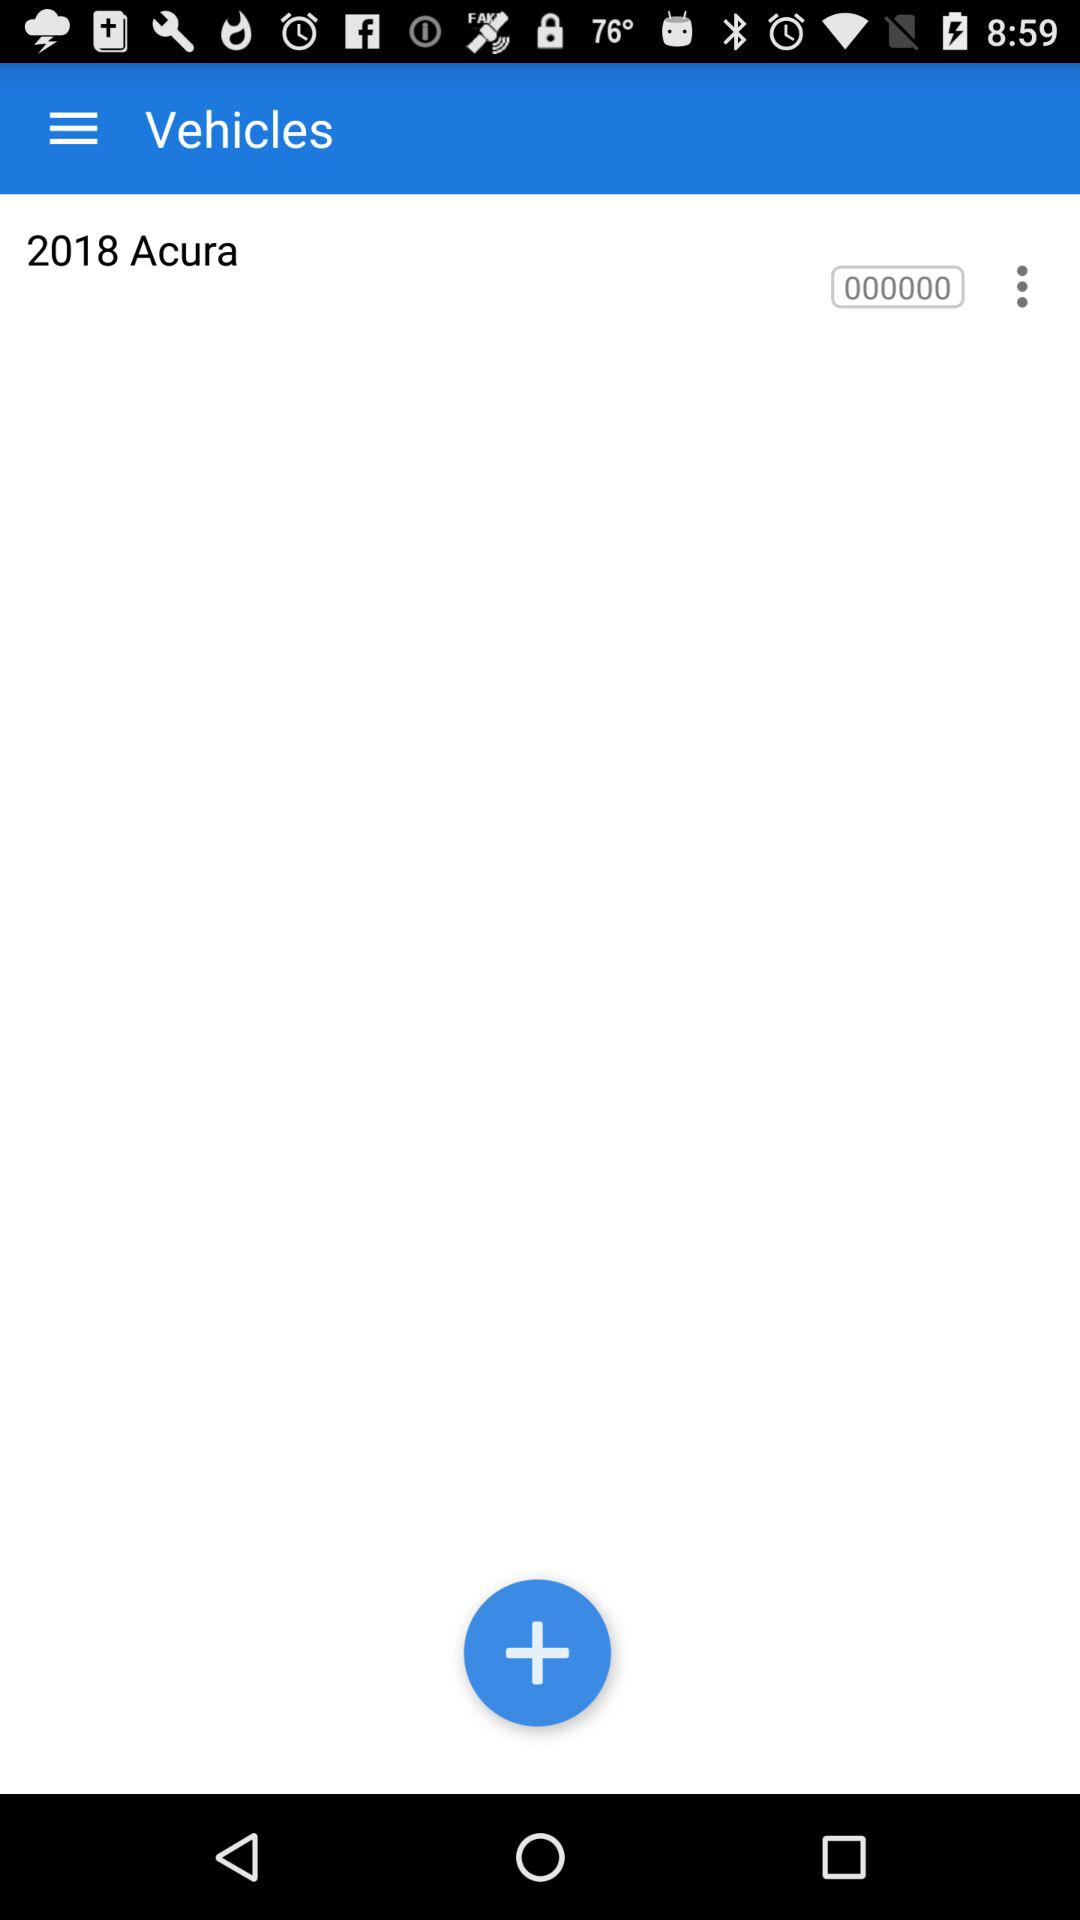What is the name of the vehicle? The name of the vehicle is "2018 Acura". 